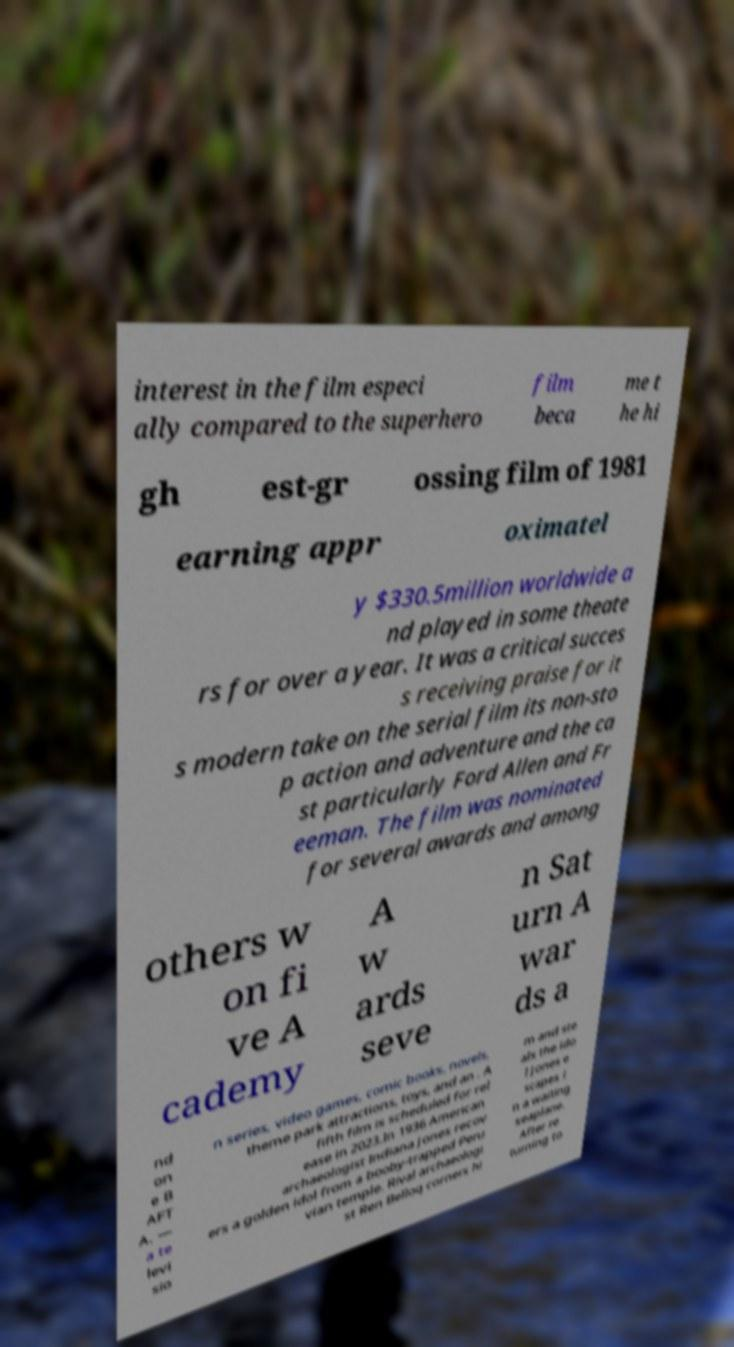Can you accurately transcribe the text from the provided image for me? interest in the film especi ally compared to the superhero film beca me t he hi gh est-gr ossing film of 1981 earning appr oximatel y $330.5million worldwide a nd played in some theate rs for over a year. It was a critical succes s receiving praise for it s modern take on the serial film its non-sto p action and adventure and the ca st particularly Ford Allen and Fr eeman. The film was nominated for several awards and among others w on fi ve A cademy A w ards seve n Sat urn A war ds a nd on e B AFT A. — a te levi sio n series, video games, comic books, novels, theme park attractions, toys, and an . A fifth film is scheduled for rel ease in 2023.In 1936 American archaeologist Indiana Jones recov ers a golden idol from a booby-trapped Peru vian temple. Rival archaeologi st Ren Belloq corners hi m and ste als the ido l Jones e scapes i n a waiting seaplane. After re turning to 